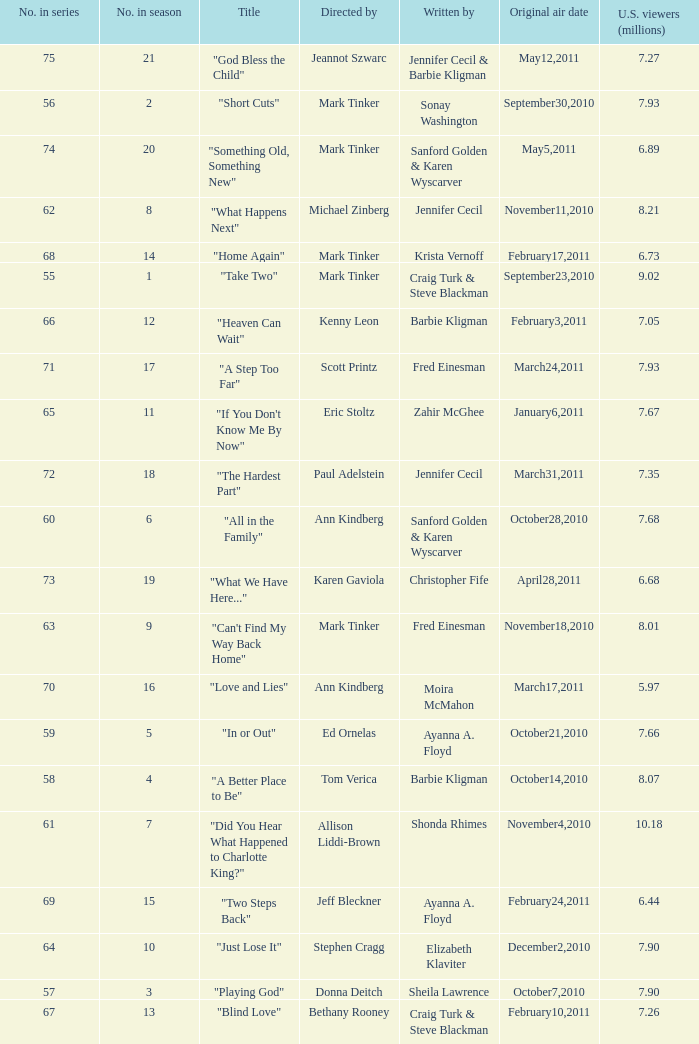What is the earliest numbered episode of the season? 1.0. 